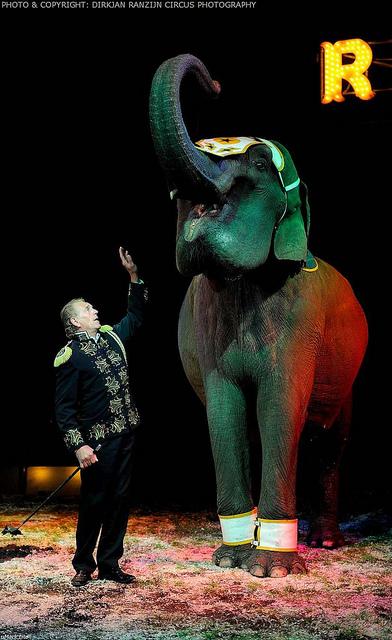Is this at a circus?
Give a very brief answer. Yes. Where is the elephant?
Concise answer only. Circus. How many legs can you see in this picture?
Write a very short answer. 5. What kind of animal is pictured?
Answer briefly. Elephant. 